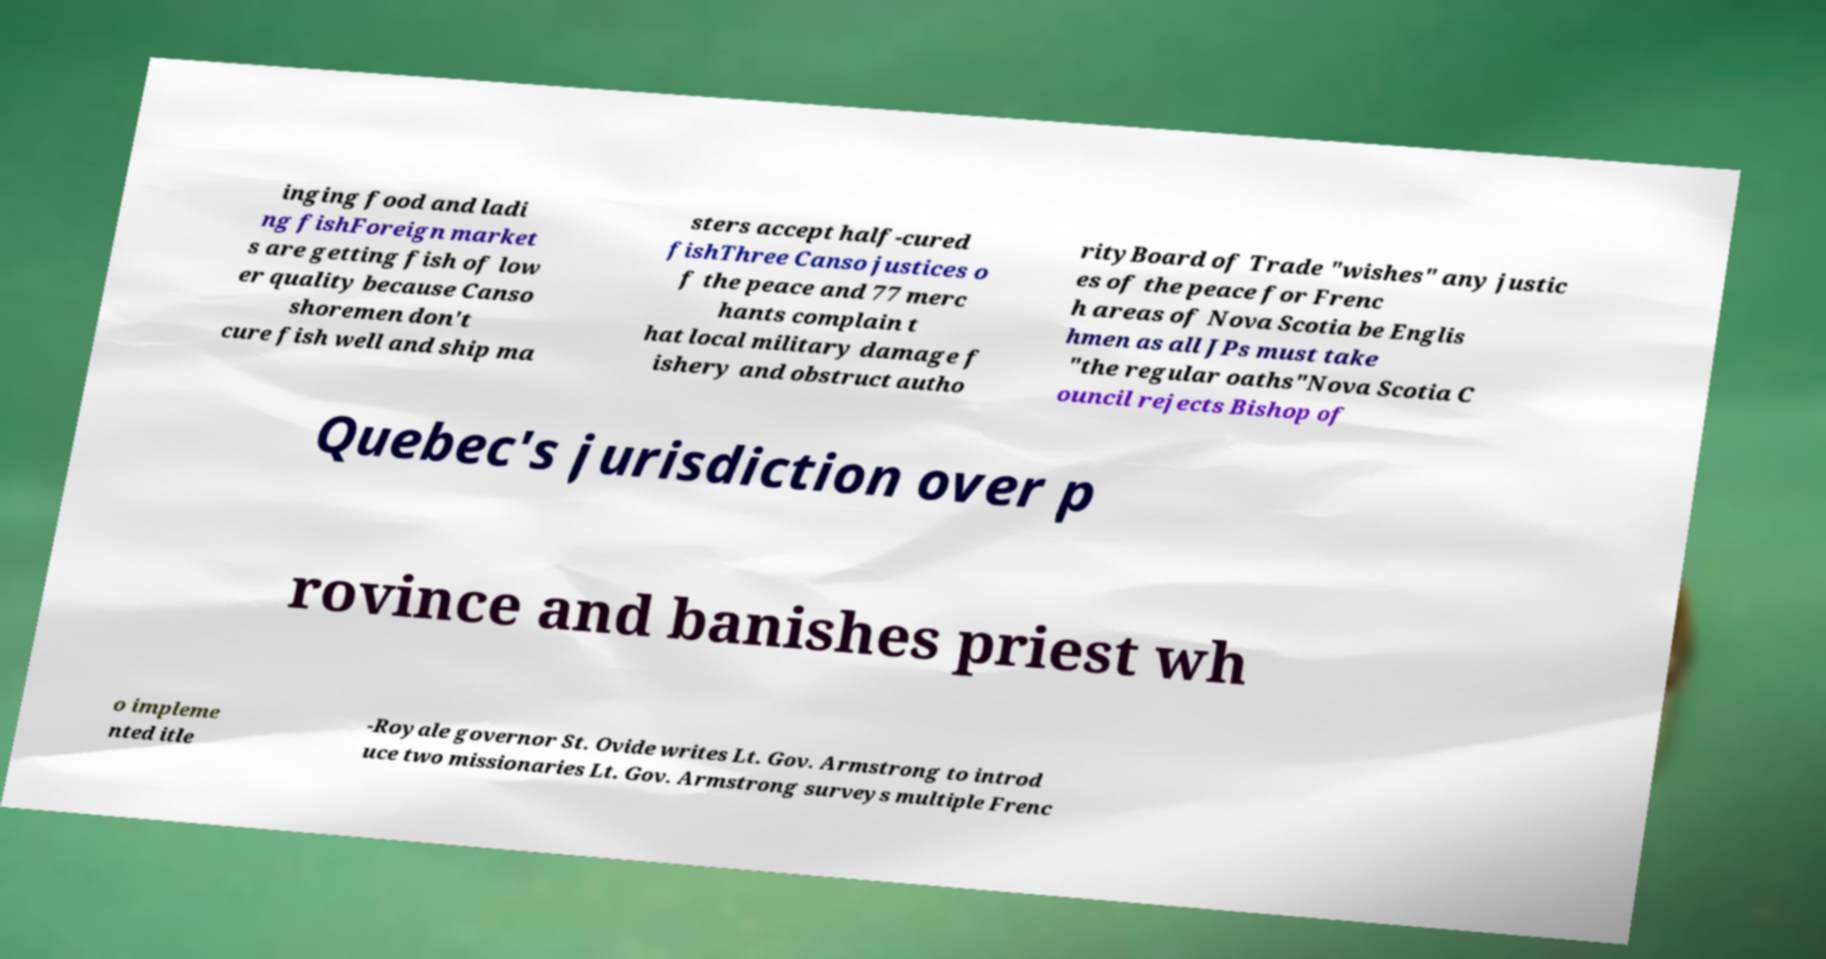Could you extract and type out the text from this image? inging food and ladi ng fishForeign market s are getting fish of low er quality because Canso shoremen don't cure fish well and ship ma sters accept half-cured fishThree Canso justices o f the peace and 77 merc hants complain t hat local military damage f ishery and obstruct autho rityBoard of Trade "wishes" any justic es of the peace for Frenc h areas of Nova Scotia be Englis hmen as all JPs must take "the regular oaths"Nova Scotia C ouncil rejects Bishop of Quebec's jurisdiction over p rovince and banishes priest wh o impleme nted itle -Royale governor St. Ovide writes Lt. Gov. Armstrong to introd uce two missionaries Lt. Gov. Armstrong surveys multiple Frenc 